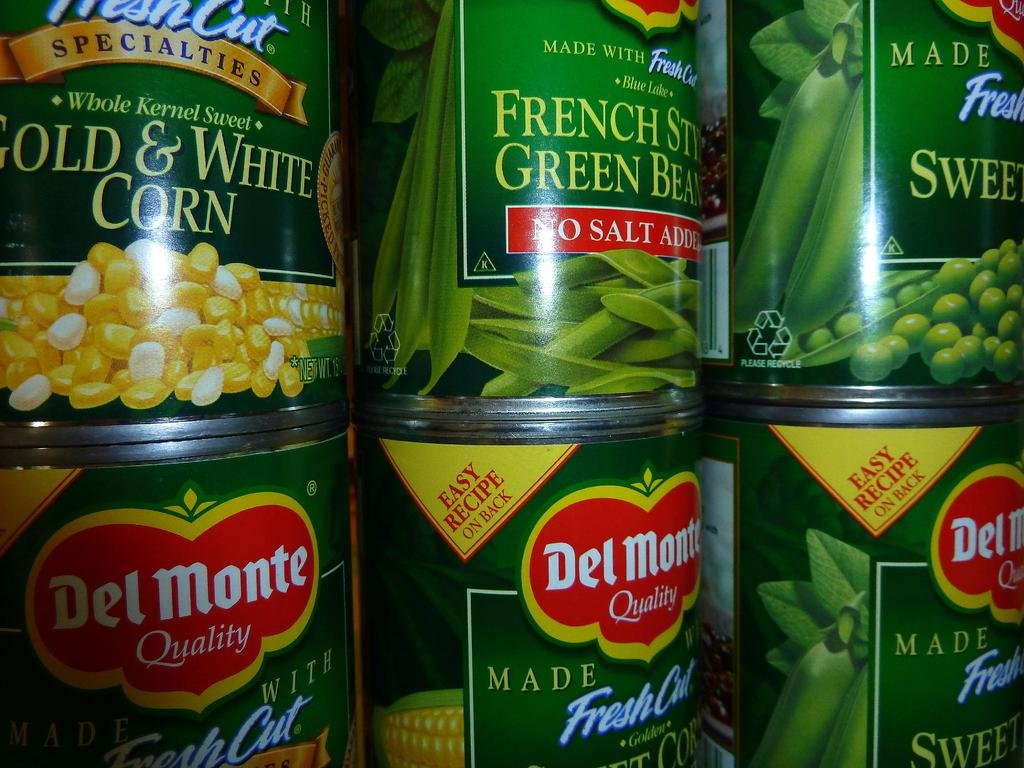How many tins are visible in the image? There are six tins in the image. What can be found on the tins? There is text on the tins. What achievement is the actor celebrating in the image? There is no actor or achievement present in the image; it only features six tins with text on them. 